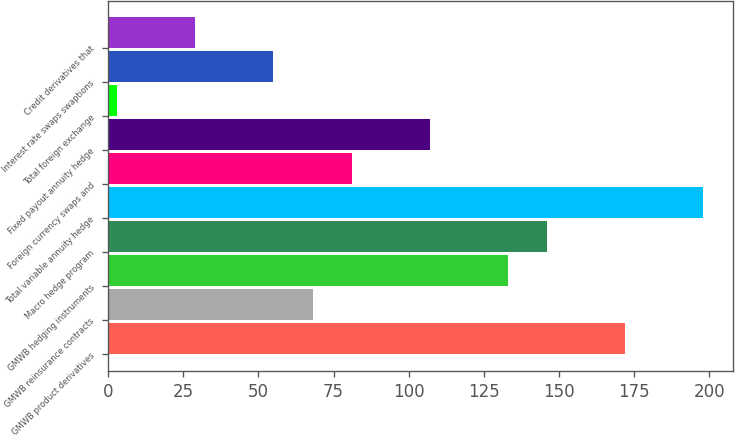<chart> <loc_0><loc_0><loc_500><loc_500><bar_chart><fcel>GMWB product derivatives<fcel>GMWB reinsurance contracts<fcel>GMWB hedging instruments<fcel>Macro hedge program<fcel>Total variable annuity hedge<fcel>Foreign currency swaps and<fcel>Fixed payout annuity hedge<fcel>Total foreign exchange<fcel>Interest rate swaps swaptions<fcel>Credit derivatives that<nl><fcel>172<fcel>68<fcel>133<fcel>146<fcel>198<fcel>81<fcel>107<fcel>3<fcel>55<fcel>29<nl></chart> 